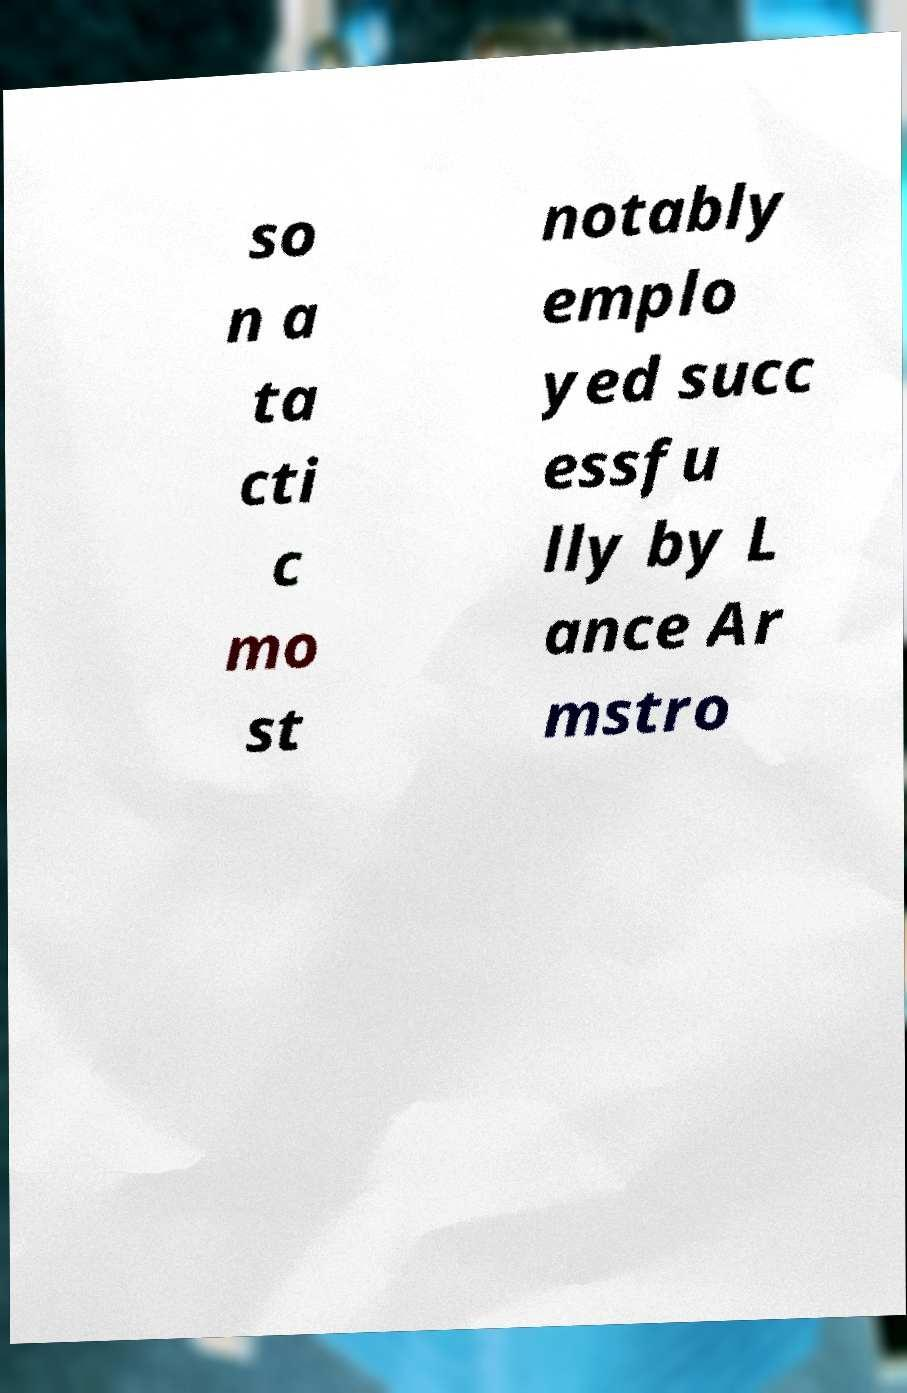Please read and relay the text visible in this image. What does it say? so n a ta cti c mo st notably emplo yed succ essfu lly by L ance Ar mstro 